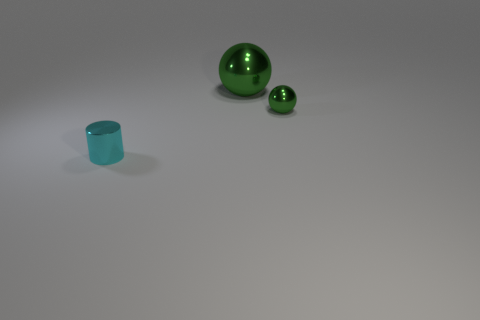The thing that is both on the left side of the small green metal object and behind the small metal cylinder is made of what material?
Make the answer very short. Metal. How many gray rubber cylinders have the same size as the metallic cylinder?
Keep it short and to the point. 0. What color is the tiny object that is behind the object that is on the left side of the large metallic ball?
Make the answer very short. Green. Is there a small cyan metal cylinder?
Offer a terse response. Yes. Is the shape of the cyan shiny object the same as the tiny green thing?
Ensure brevity in your answer.  No. What size is the other shiny object that is the same color as the large metallic object?
Make the answer very short. Small. How many big green metal objects are left of the tiny thing to the right of the cylinder?
Give a very brief answer. 1. What number of things are both in front of the tiny green sphere and behind the small green metallic object?
Offer a terse response. 0. How many things are either large purple matte things or tiny things right of the big green shiny ball?
Your answer should be very brief. 1. The cyan thing that is the same material as the large green thing is what size?
Provide a succinct answer. Small. 